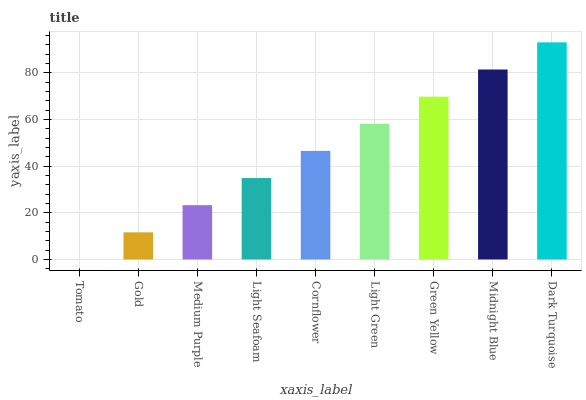Is Tomato the minimum?
Answer yes or no. Yes. Is Dark Turquoise the maximum?
Answer yes or no. Yes. Is Gold the minimum?
Answer yes or no. No. Is Gold the maximum?
Answer yes or no. No. Is Gold greater than Tomato?
Answer yes or no. Yes. Is Tomato less than Gold?
Answer yes or no. Yes. Is Tomato greater than Gold?
Answer yes or no. No. Is Gold less than Tomato?
Answer yes or no. No. Is Cornflower the high median?
Answer yes or no. Yes. Is Cornflower the low median?
Answer yes or no. Yes. Is Midnight Blue the high median?
Answer yes or no. No. Is Gold the low median?
Answer yes or no. No. 